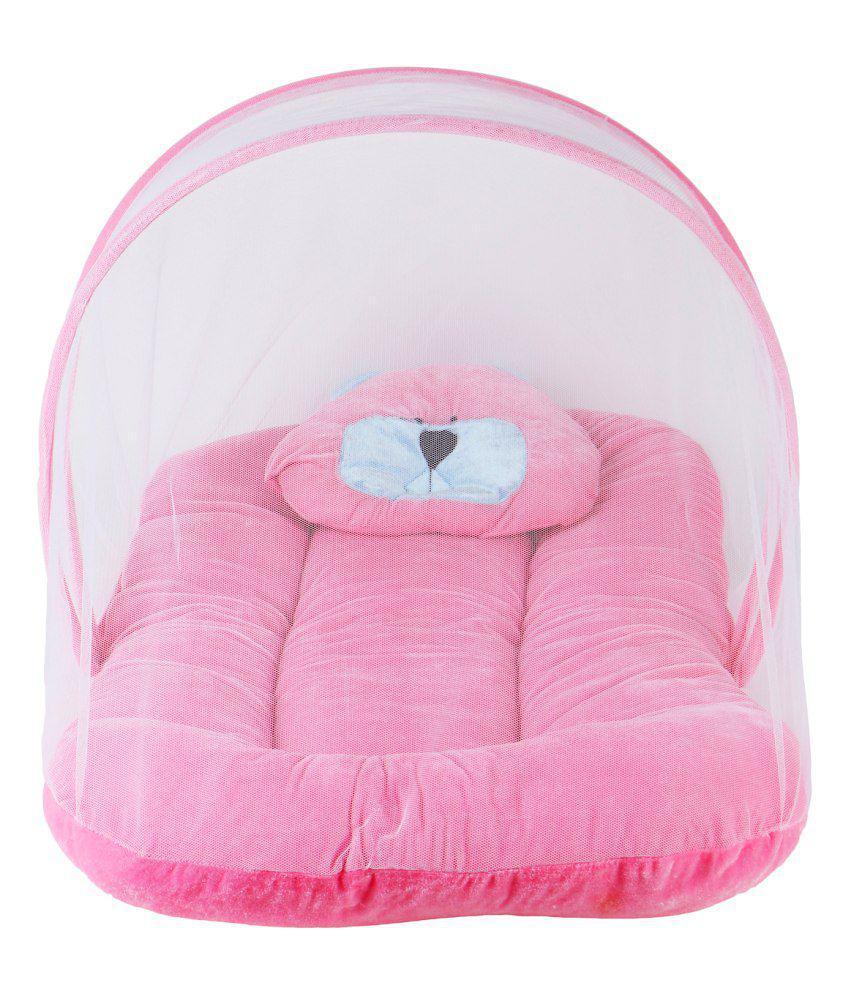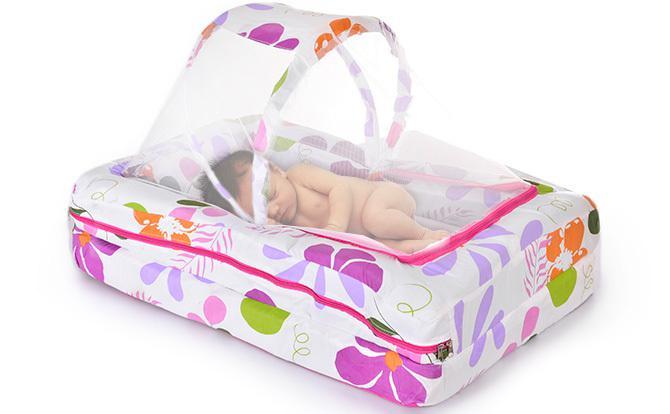The first image is the image on the left, the second image is the image on the right. Examine the images to the left and right. Is the description "In one image, the baby bed is solid pink and has a shell cover over one end." accurate? Answer yes or no. Yes. 